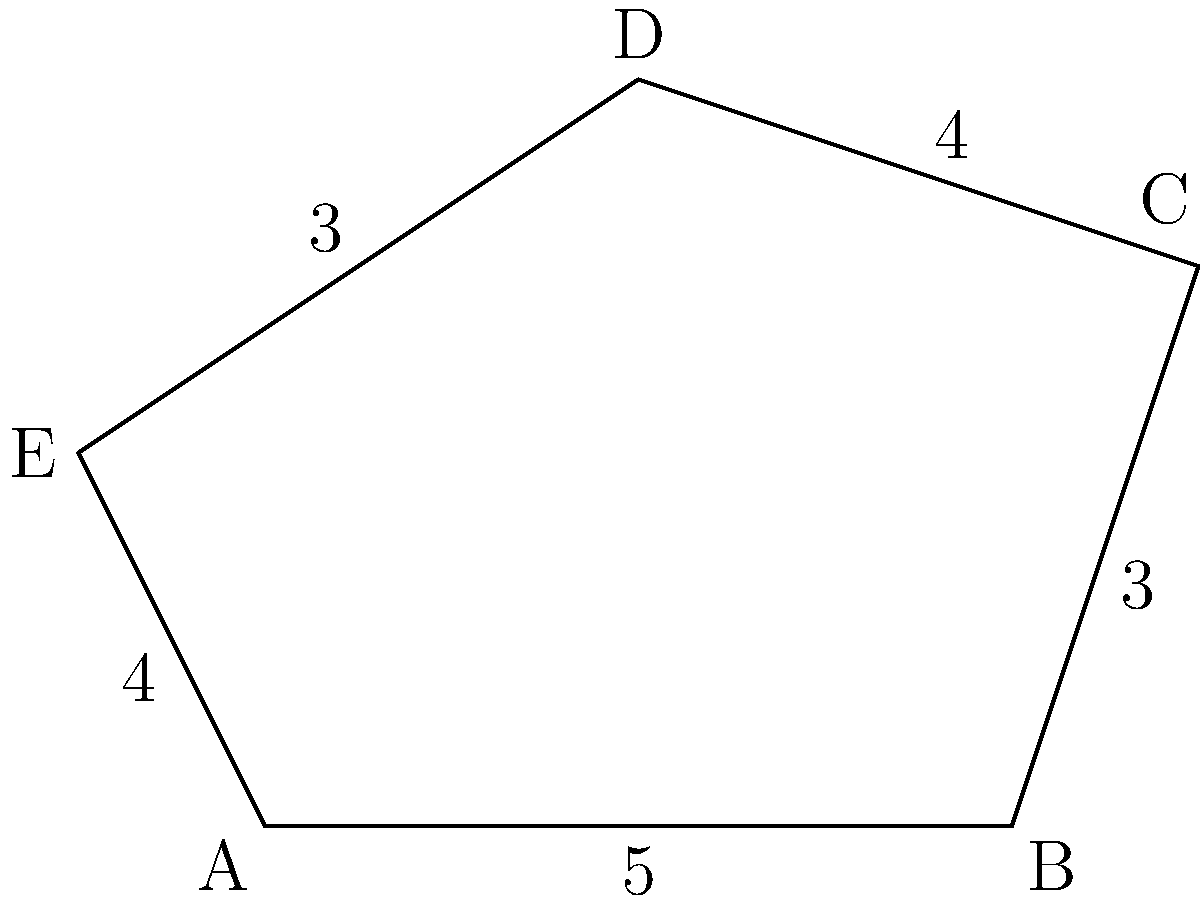In memory of our childhood friend Herman, let's solve a geometry problem he might have enjoyed. Consider the irregular pentagon ABCDE shown in the figure. Given that the side lengths are AB = 5 units, BC = 3 units, CD = 4 units, DE = 3 units, and EA = 4 units, what is the perimeter of the pentagon? To find the perimeter of the irregular pentagon ABCDE, we need to sum up the lengths of all its sides. Let's go through this step-by-step:

1. Side AB: 5 units
2. Side BC: 3 units
3. Side CD: 4 units
4. Side DE: 3 units
5. Side EA: 4 units

Now, we simply add these lengths together:

$$\text{Perimeter} = AB + BC + CD + DE + EA$$
$$\text{Perimeter} = 5 + 3 + 4 + 3 + 4$$
$$\text{Perimeter} = 19 \text{ units}$$

Therefore, the perimeter of the irregular pentagon ABCDE is 19 units.
Answer: 19 units 